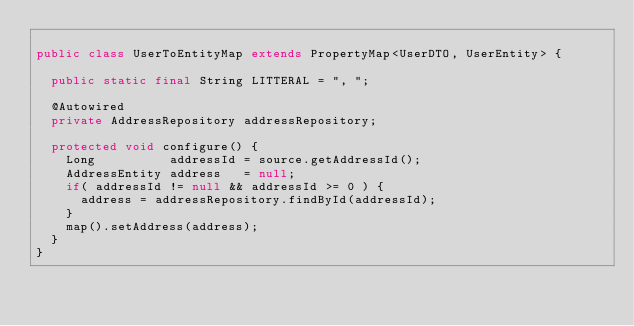<code> <loc_0><loc_0><loc_500><loc_500><_Java_>
public class UserToEntityMap extends PropertyMap<UserDTO, UserEntity> {

  public static final String LITTERAL = ", ";

  @Autowired
  private AddressRepository addressRepository;

  protected void configure() {
    Long          addressId = source.getAddressId();
    AddressEntity address   = null;
    if( addressId != null && addressId >= 0 ) {
      address = addressRepository.findById(addressId);
    }
    map().setAddress(address);
  }
}

</code> 